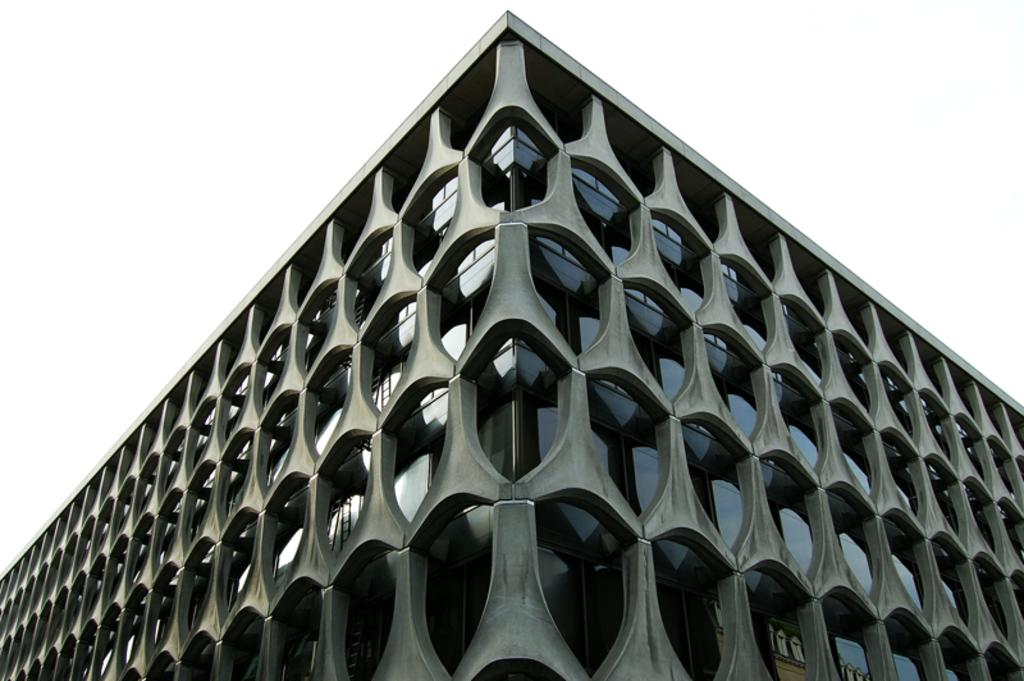What type of structure is present in the image? There is a building in the image. What can be seen in the background of the image? The sky is visible in the background of the image. How many jellyfish are swimming in the sky in the image? There are no jellyfish present in the image, and the sky is not a body of water where jellyfish would be found. 